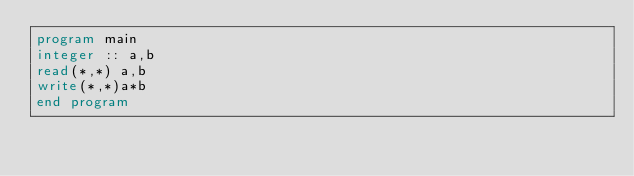<code> <loc_0><loc_0><loc_500><loc_500><_FORTRAN_>program main
integer :: a,b
read(*,*) a,b
write(*,*)a*b
end program</code> 